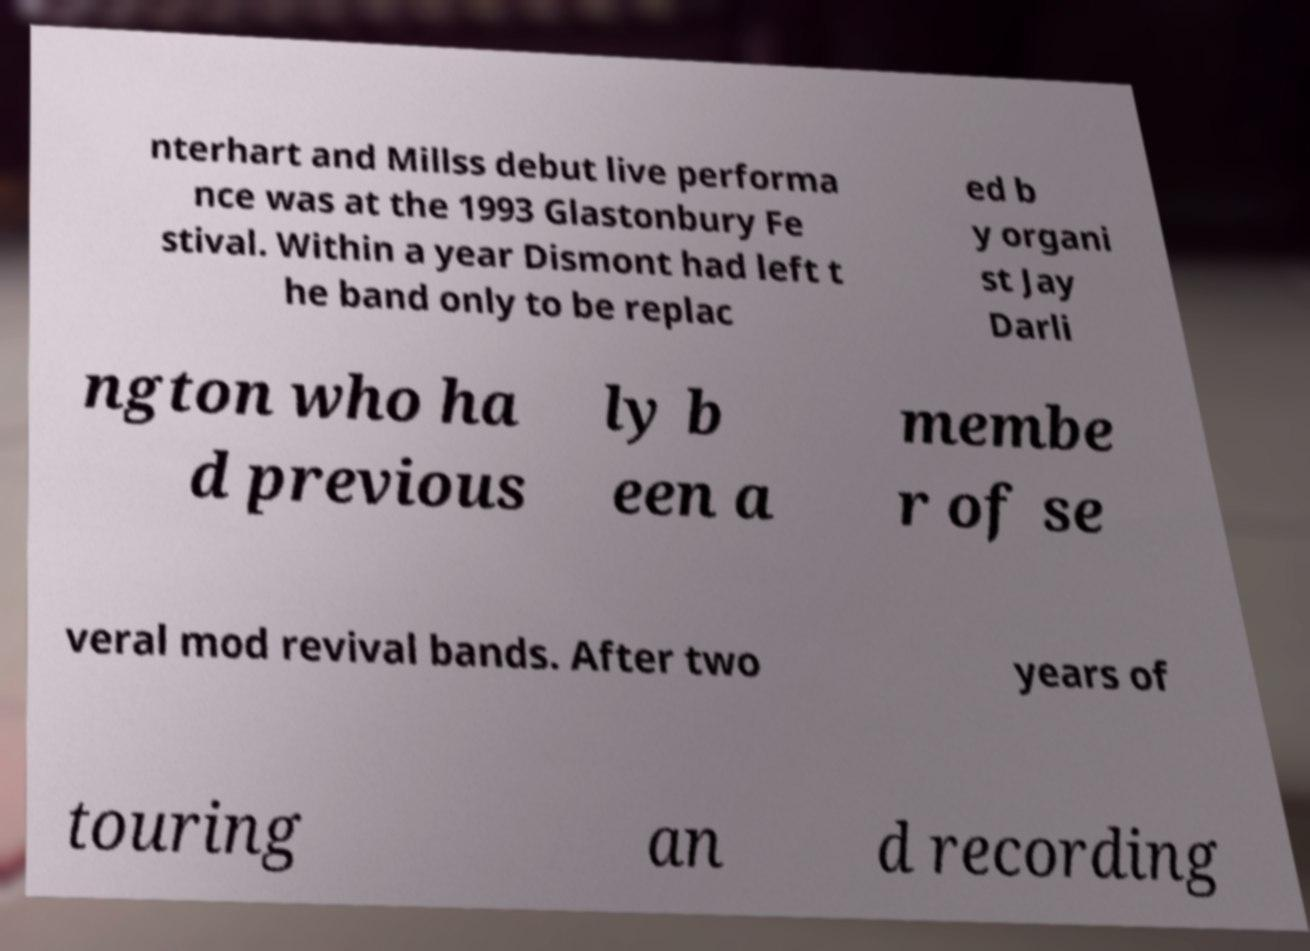What messages or text are displayed in this image? I need them in a readable, typed format. nterhart and Millss debut live performa nce was at the 1993 Glastonbury Fe stival. Within a year Dismont had left t he band only to be replac ed b y organi st Jay Darli ngton who ha d previous ly b een a membe r of se veral mod revival bands. After two years of touring an d recording 